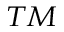<formula> <loc_0><loc_0><loc_500><loc_500>^ { T M }</formula> 